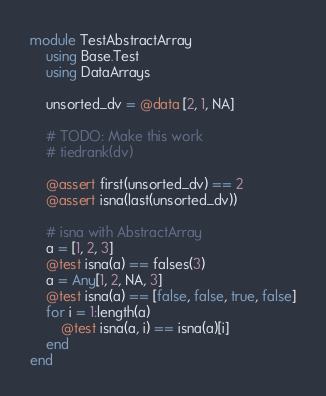Convert code to text. <code><loc_0><loc_0><loc_500><loc_500><_Julia_>module TestAbstractArray
    using Base.Test
    using DataArrays

    unsorted_dv = @data [2, 1, NA]

    # TODO: Make this work
    # tiedrank(dv)

    @assert first(unsorted_dv) == 2
    @assert isna(last(unsorted_dv))

    # isna with AbstractArray
    a = [1, 2, 3]
    @test isna(a) == falses(3)
    a = Any[1, 2, NA, 3]
    @test isna(a) == [false, false, true, false]
    for i = 1:length(a)
	    @test isna(a, i) == isna(a)[i]
	end
end
</code> 